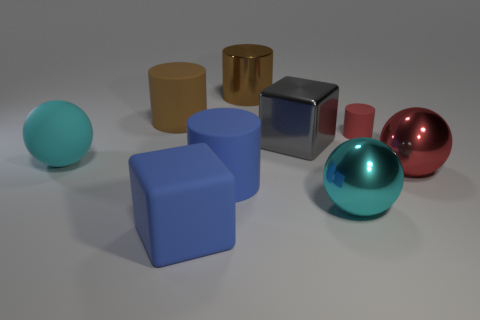Add 1 big gray objects. How many objects exist? 10 Subtract all cubes. How many objects are left? 7 Add 2 big red metallic objects. How many big red metallic objects are left? 3 Add 4 large cyan spheres. How many large cyan spheres exist? 6 Subtract 0 purple blocks. How many objects are left? 9 Subtract all large balls. Subtract all metal cubes. How many objects are left? 5 